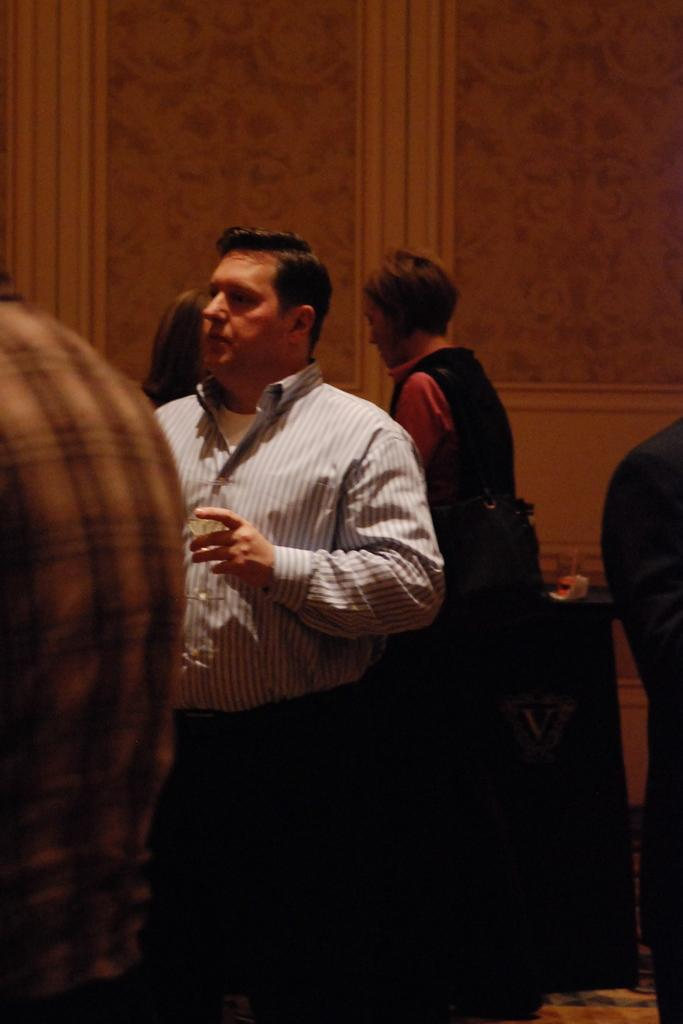What type of location is depicted in the image? The image shows an inside view of a building. Can you describe the people visible inside the building? There are people visible inside the building. What architectural feature can be seen at the top of the image? There is a wall at the top of the image. How does the grandmother wash her wound in the image? There is no grandmother or wound present in the image. 